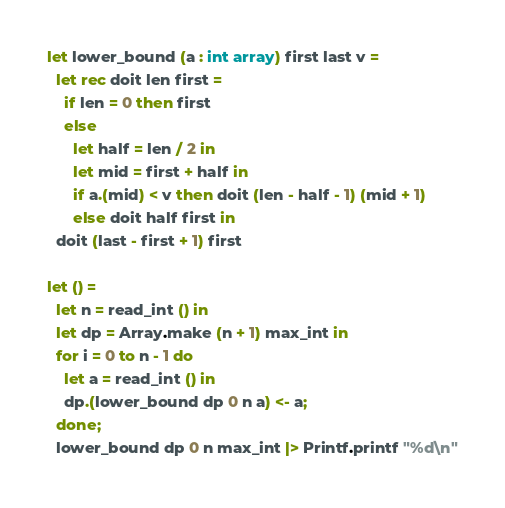<code> <loc_0><loc_0><loc_500><loc_500><_OCaml_>let lower_bound (a : int array) first last v =
  let rec doit len first =
    if len = 0 then first
    else
      let half = len / 2 in
      let mid = first + half in
      if a.(mid) < v then doit (len - half - 1) (mid + 1)
      else doit half first in
  doit (last - first + 1) first

let () =
  let n = read_int () in
  let dp = Array.make (n + 1) max_int in
  for i = 0 to n - 1 do
    let a = read_int () in
    dp.(lower_bound dp 0 n a) <- a;
  done;
  lower_bound dp 0 n max_int |> Printf.printf "%d\n"</code> 